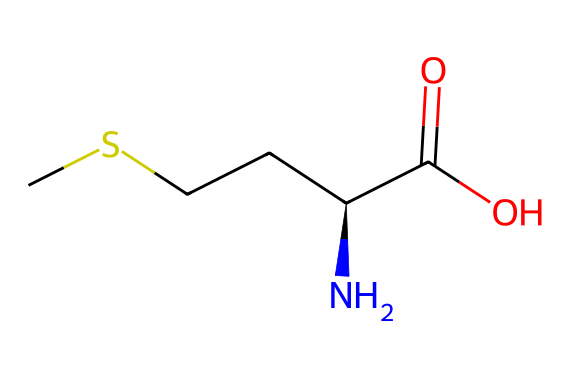What is the name of this compound? The SMILES representation corresponds to methionine, an essential amino acid that plays a key role in various biological processes.
Answer: methionine How many carbon atoms are in this molecule? By analyzing the SMILES, we see there are five carbon atoms: one in the methyl group, one connected to the sulfur, and the remaining three in the carbon chain.
Answer: five What functional group is present at the terminal end of this molecule? The presence of the carboxylic acid functional group (-COOH) can be identified at the terminal end of the structure, indicated by the "C(=O)O" in SMILES.
Answer: carboxylic acid How many nitrogen atoms are there in this molecule? The SMILES representation has one nitrogen atom, which is shown as "N" in the side chain of the structure.
Answer: one Which part of the structure indicates the presence of sulfur? The sulfur atom is denoted by "S" in the SMILES, indicating it connects to a carbon atom, confirming it is part of the side chain of methionine.
Answer: sulfur What type of amine is present in this compound? The primary amine is identified in the structure by the fact that the nitrogen atom is bound to two hydrogen atoms and one carbon atom.
Answer: primary amine Is methionine a polar or nonpolar amino acid? Methionine contains both hydrophobic (due to its aliphatic side chain) and polar characteristics (due to the terminal groups), thus it is generally considered nonpolar.
Answer: nonpolar 